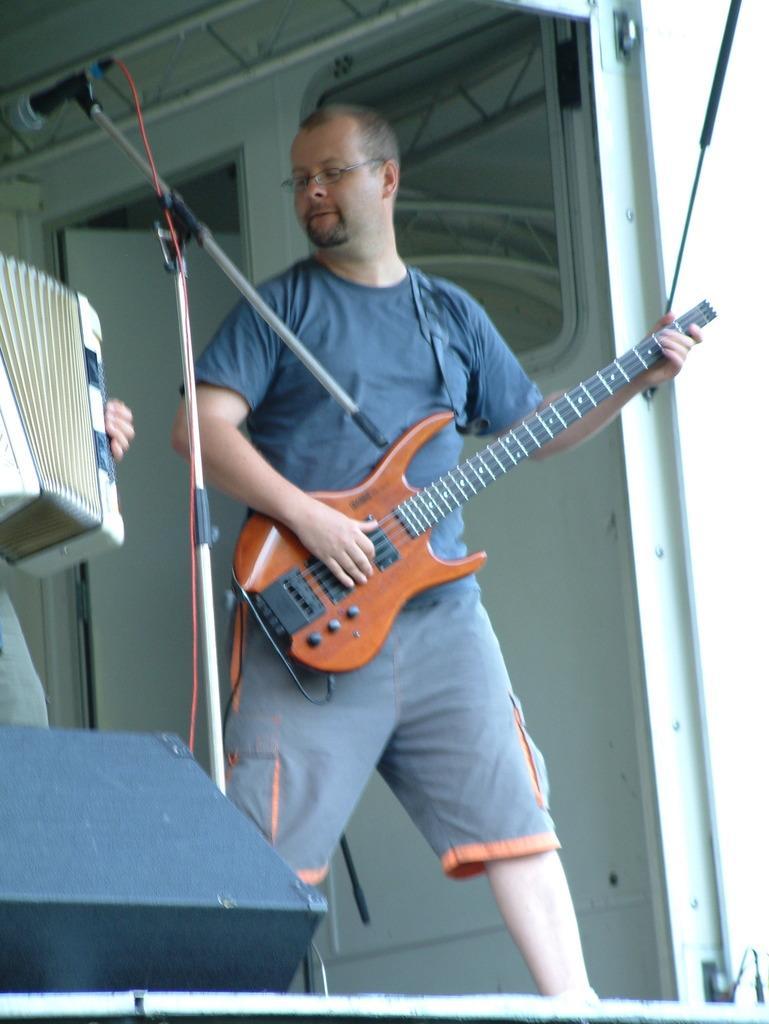In one or two sentences, can you explain what this image depicts? In this picture their is a man who is holding the guitar in his hand and there is a mic beside him. In the background there is a door. on the left side their is a accordion played by a man. 